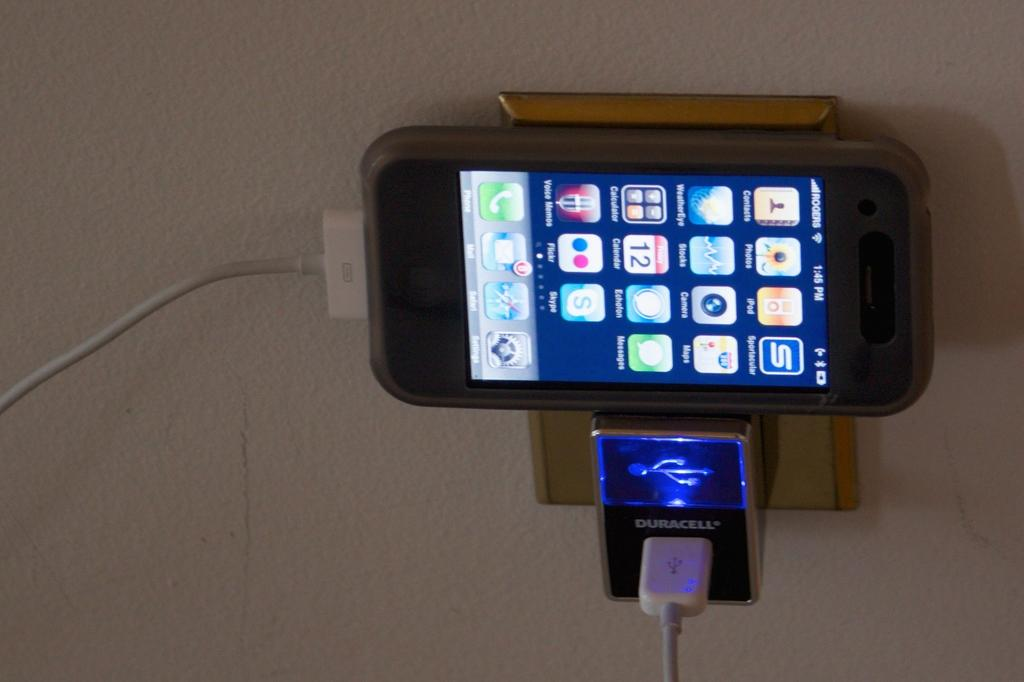<image>
Render a clear and concise summary of the photo. Phone charging and showing the current time is 1:45. 